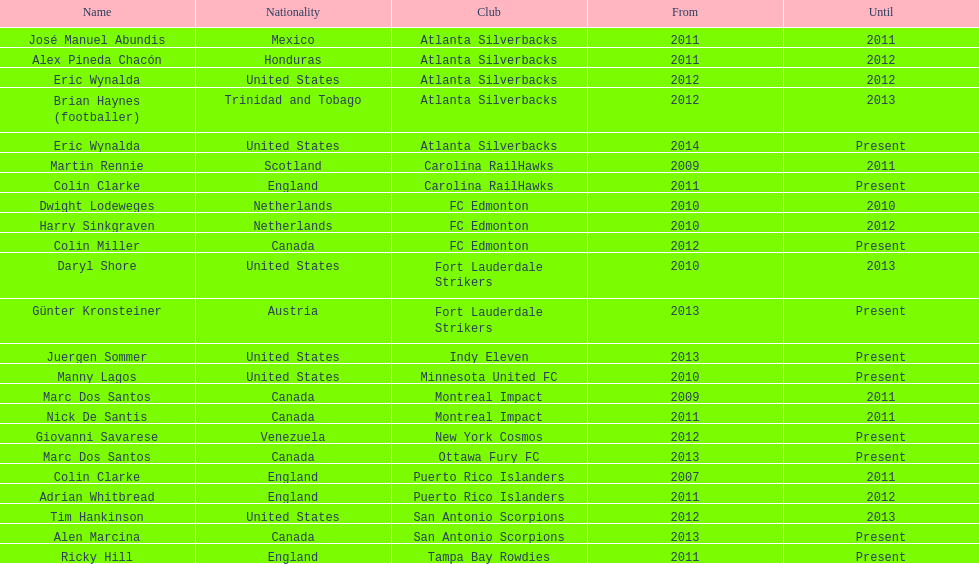In which common country did marc dos santos and colin miller serve as coaches? Canada. 